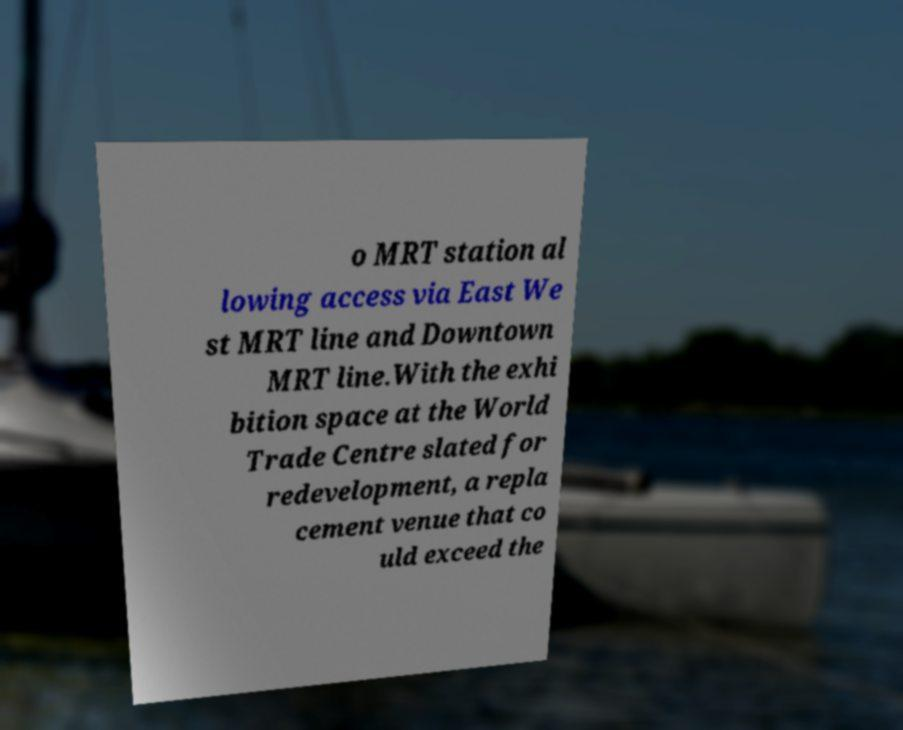For documentation purposes, I need the text within this image transcribed. Could you provide that? o MRT station al lowing access via East We st MRT line and Downtown MRT line.With the exhi bition space at the World Trade Centre slated for redevelopment, a repla cement venue that co uld exceed the 